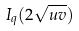Convert formula to latex. <formula><loc_0><loc_0><loc_500><loc_500>I _ { q } ( 2 \sqrt { u v } )</formula> 